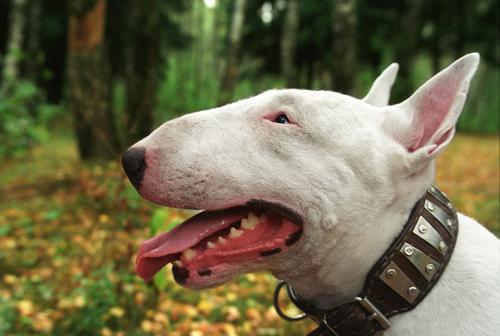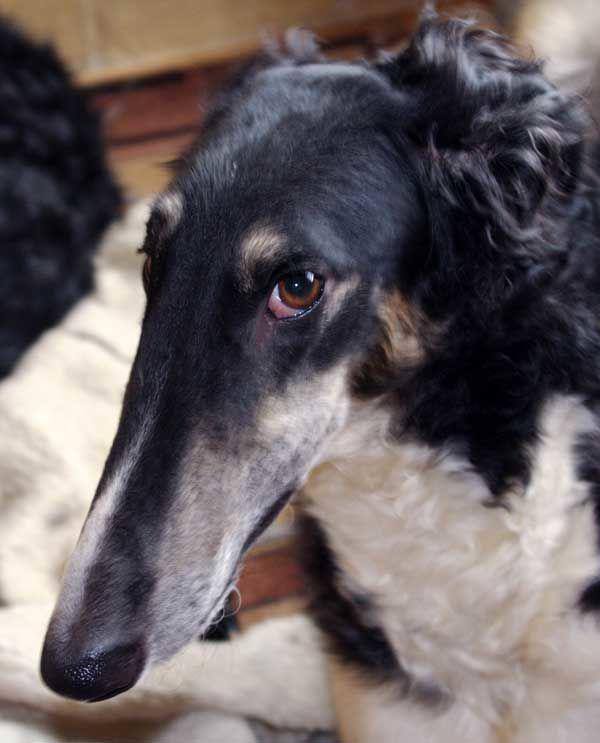The first image is the image on the left, the second image is the image on the right. For the images displayed, is the sentence "There is a Basset Hound in the image on the left." factually correct? Answer yes or no. No. The first image is the image on the left, the second image is the image on the right. For the images shown, is this caption "At least one dog has long floppy brown ears, both front paws on the surface in front of it, and a body turned toward the camera." true? Answer yes or no. No. 